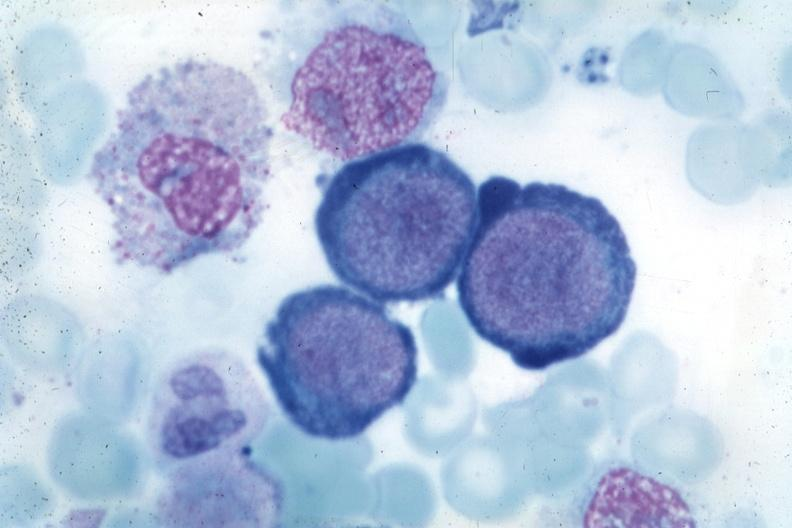s bone marrow present?
Answer the question using a single word or phrase. Yes 